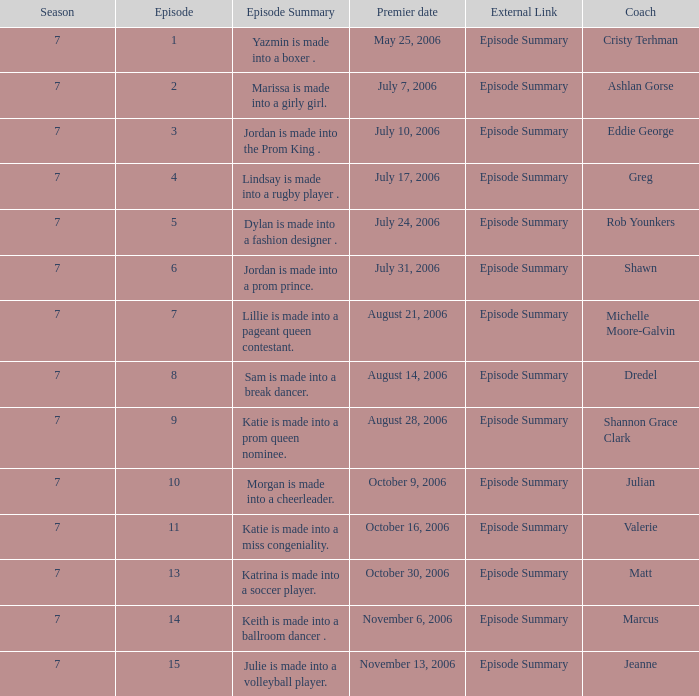How many episodes have Valerie? 1.0. 